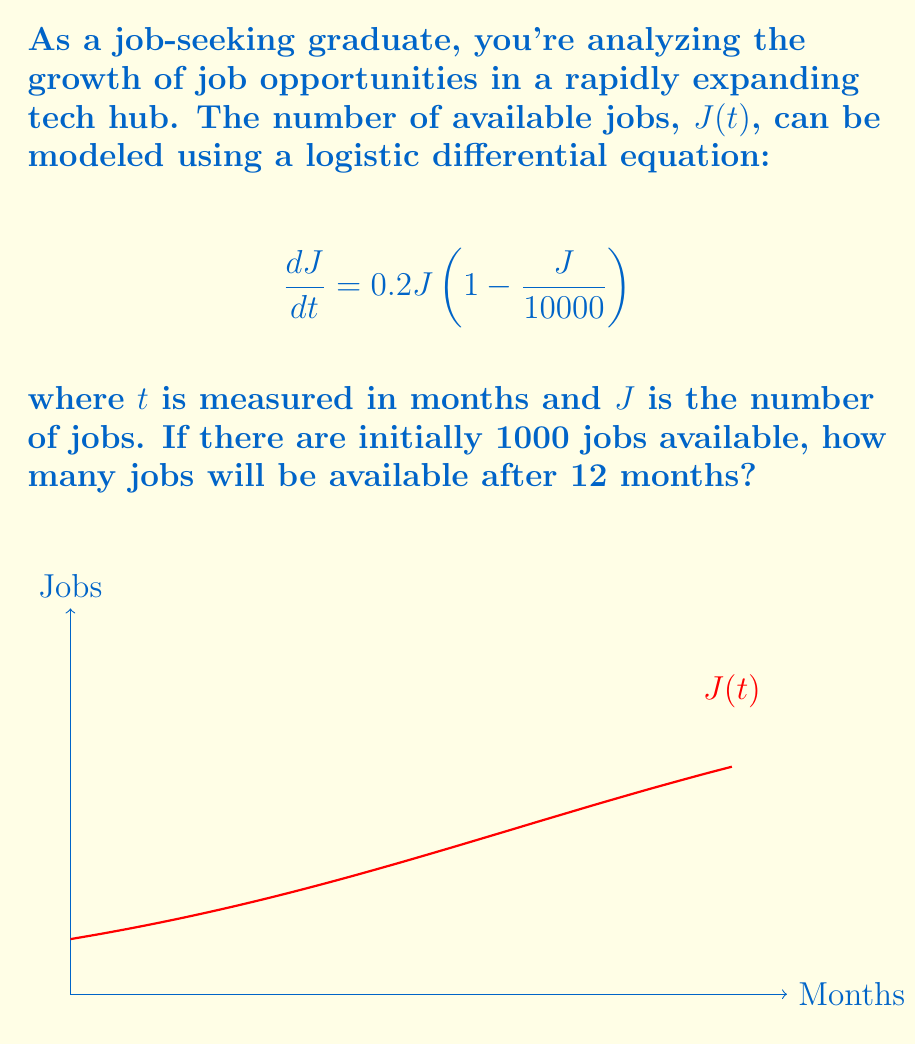Teach me how to tackle this problem. To solve this problem, we'll follow these steps:

1) The given logistic differential equation is:
   $$\frac{dJ}{dt} = 0.2J(1 - \frac{J}{10000})$$

2) The general solution to this equation is:
   $$J(t) = \frac{K}{1 + Ce^{-rt}}$$
   where K is the carrying capacity (10000 in this case), r is the growth rate (0.2), and C is a constant we need to determine.

3) We're given the initial condition: J(0) = 1000. Let's use this to find C:
   $$1000 = \frac{10000}{1 + C}$$
   $$C = 9$$

4) Now we have the specific solution:
   $$J(t) = \frac{10000}{1 + 9e^{-0.2t}}$$

5) To find J(12), we simply substitute t = 12:
   $$J(12) = \frac{10000}{1 + 9e^{-0.2(12)}}$$

6) Calculating this:
   $$J(12) = \frac{10000}{1 + 9e^{-2.4}} \approx 5052.91$$

7) Rounding to the nearest whole number (as we can't have fractional jobs):
   J(12) ≈ 5053 jobs
Answer: 5053 jobs 